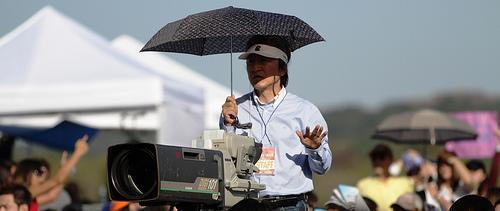How many white tents are there?
Give a very brief answer. 2. 